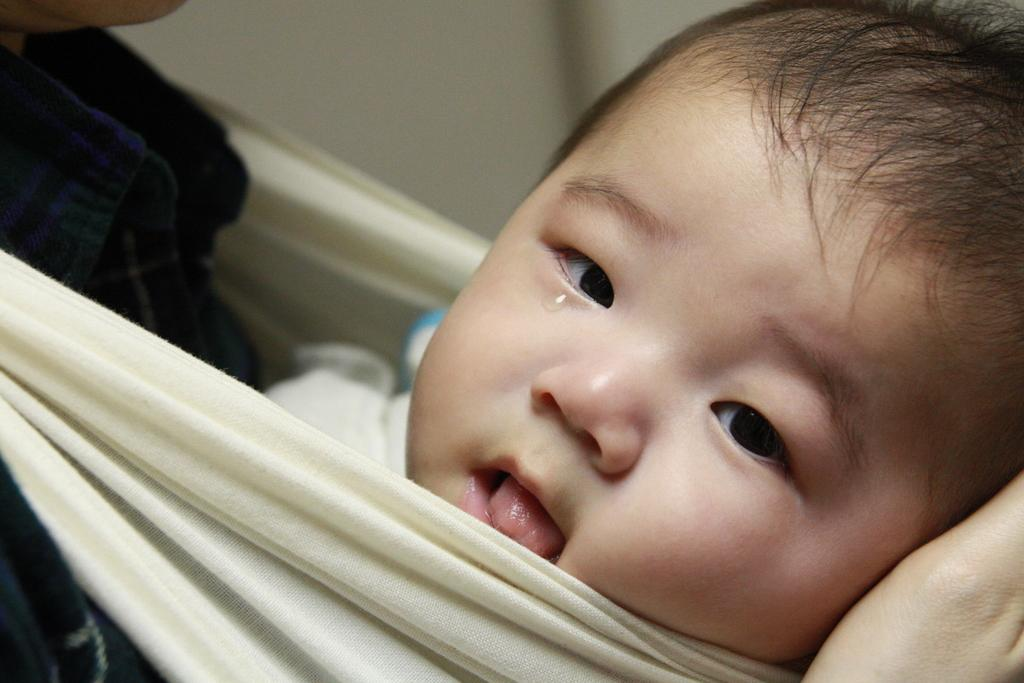What is the main subject of the image? There is a baby in the image. Is there anyone else present in the image? Yes, there is a person in the image. Can you describe the setting of the image? The image may have been taken in a room. What type of weather can be seen in the image? There is no information about the weather in the image, as it appears to have been taken indoors. Can you describe the squirrel in the image? There is no squirrel present in the image; it features a baby and a person. 